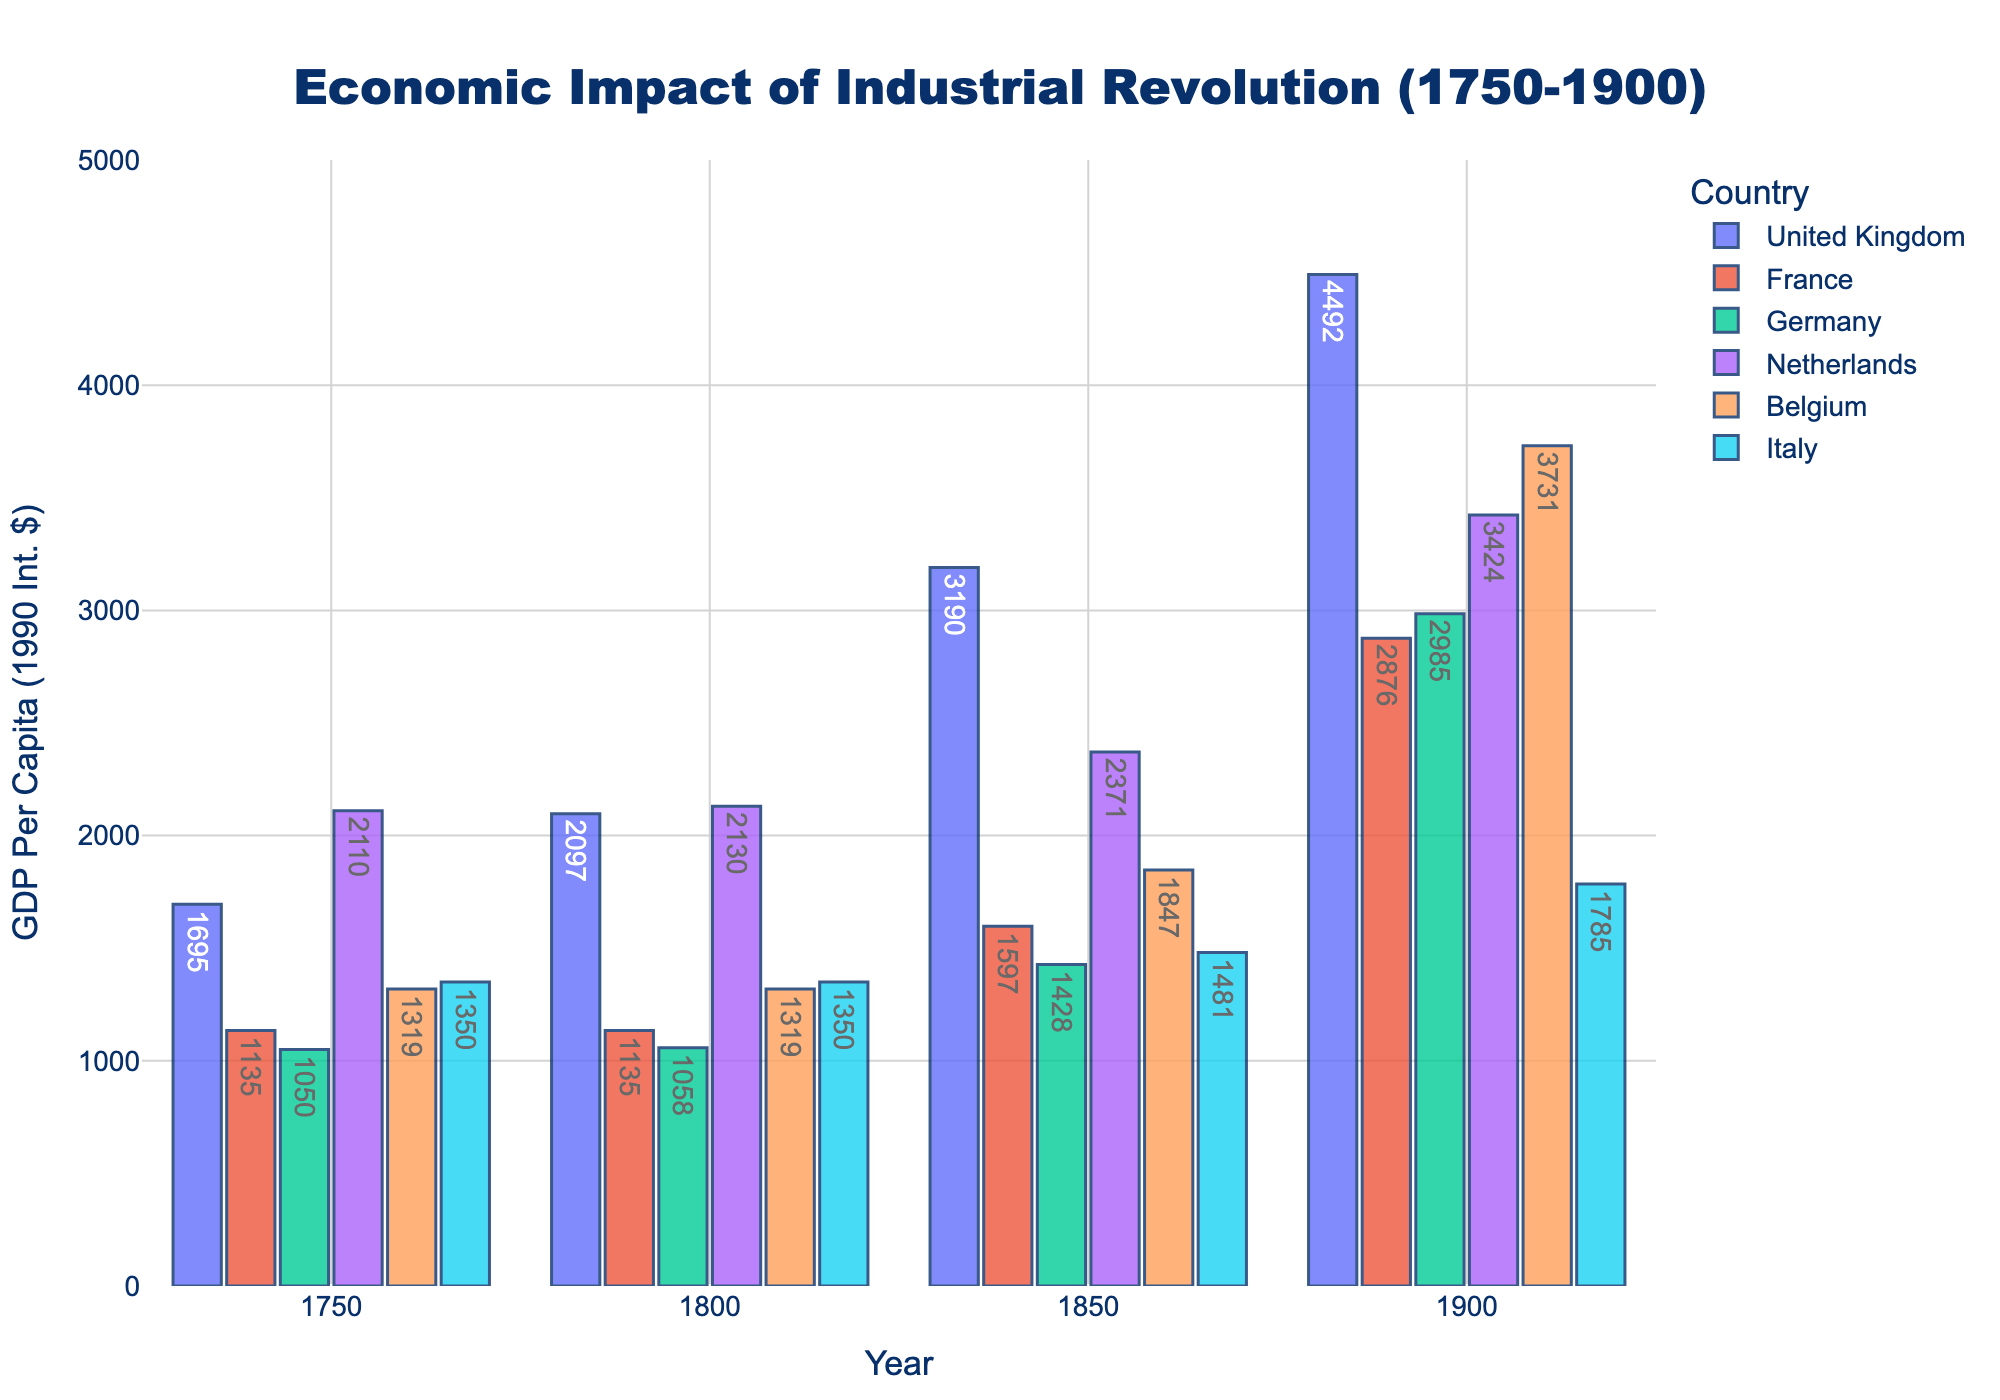What was the GDP per capita of France in 1800 and 1850? Refer to the French GDP per capita values for the years 1800 and 1850 on the chart. For 1800, it's 1135, and for 1850, it's 1597.
Answer: 1135, 1597 Which country had the highest GDP per capita in 1850? Compare the heights of the bars in 1850 for each country. The United Kingdom has the tallest bar, indicating it had the highest GDP per capita, which is 3190.
Answer: United Kingdom What is the difference in GDP per capita between Germany and Italy in 1900? Locate the bars for Germany and Italy in the year 1900. Germany's GDP per capita is 2985, and Italy's is 1785. Subtract Italy's value from Germany's: 2985 - 1785 = 1200.
Answer: 1200 How did the GDP per capita of Belgium change from 1750 to 1900? Identify the bars for Belgium in 1750 and 1900. In 1750, the GDP per capita is 1319; in 1900, it is 3731. The change is calculated as: 3731 - 1319 = 2412.
Answer: It increased by 2412 Which country experienced the smallest increase in GDP per capita from 1750 to 1800? Compare the difference in GDP per capita for each country between 1750 and 1800. For the United Kingdom (2097-1695=402), for France (1135-1135=0), for Germany (1058-1050=8), for Netherlands (2130-2110=20), for Belgium (1319-1319=0), and for Italy (1350-1350=0). France, Belgium, and Italy show no increase, so they all experienced the smallest increase.
Answer: France, Belgium, Italy What was the average GDP per capita for the Netherlands across all years shown (1750, 1800, 1850, 1900)? Add the GDP per capita values for the Netherlands: 2110 (1750) + 2130 (1800) + 2371 (1850) + 3424 (1900), which equals 10035. Divide by the number of years (4): 10035 / 4 = 2508.75.
Answer: 2508.75 In which year was the GDP per capita of Germany lower than the GDP per capita of France? Compare the bar heights for Germany and France in each year. In 1750 and 1800, Germany's bars (1050, 1058) are shorter than France's (1135, 1135).
Answer: 1750, 1800 Which country showed the most significant overall growth in GDP per capita between 1750 and 1900? To find the overall growth, calculate the change for each country: 
- United Kingdom: 4492 - 1695 = 2797
- France: 2876 - 1135 = 1741
- Germany: 2985 - 1050 = 1935
- Netherlands: 3424 - 2110 = 1314
- Belgium: 3731 - 1319 = 2412
- Italy: 1785 - 1350 = 435 
The United Kingdom has the largest increase with 2797.
Answer: United Kingdom How many countries had a GDP per capita greater than 2000 in 1900? Identify the bars for the year 1900 and check which are greater than 2000. The countries are the United Kingdom (4492), France (2876), Germany (2985), Netherlands (3424), and Belgium (3731). The count is 5.
Answer: 5 Which year showed the smallest GDP per capita for Italy? Compare the heights of the bars for Italy across all years. The smallest value is in 1750 and 1800, both at 1350.
Answer: 1750, 1800 